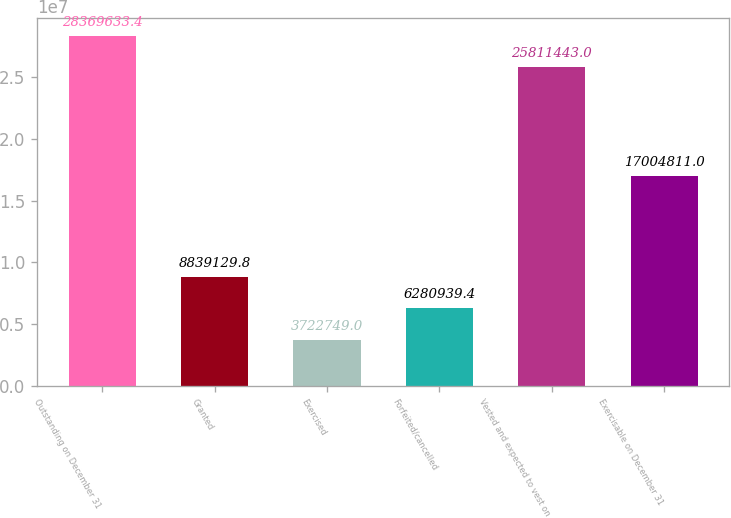Convert chart. <chart><loc_0><loc_0><loc_500><loc_500><bar_chart><fcel>Outstanding on December 31<fcel>Granted<fcel>Exercised<fcel>Forfeited/cancelled<fcel>Vested and expected to vest on<fcel>Exercisable on December 31<nl><fcel>2.83696e+07<fcel>8.83913e+06<fcel>3.72275e+06<fcel>6.28094e+06<fcel>2.58114e+07<fcel>1.70048e+07<nl></chart> 